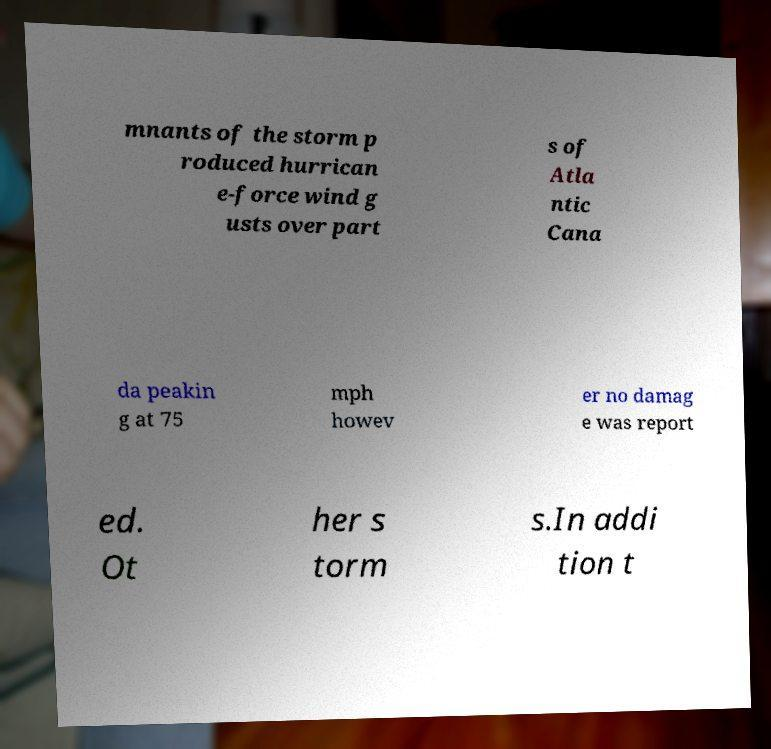Please read and relay the text visible in this image. What does it say? mnants of the storm p roduced hurrican e-force wind g usts over part s of Atla ntic Cana da peakin g at 75 mph howev er no damag e was report ed. Ot her s torm s.In addi tion t 